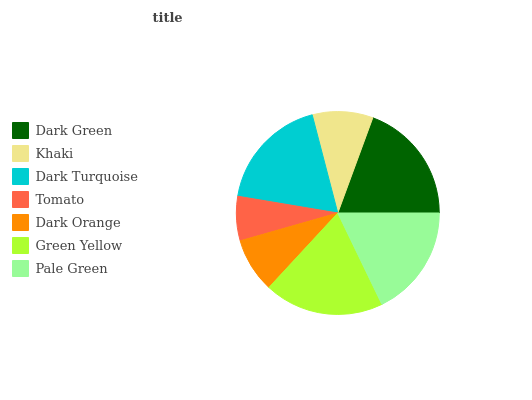Is Tomato the minimum?
Answer yes or no. Yes. Is Dark Green the maximum?
Answer yes or no. Yes. Is Khaki the minimum?
Answer yes or no. No. Is Khaki the maximum?
Answer yes or no. No. Is Dark Green greater than Khaki?
Answer yes or no. Yes. Is Khaki less than Dark Green?
Answer yes or no. Yes. Is Khaki greater than Dark Green?
Answer yes or no. No. Is Dark Green less than Khaki?
Answer yes or no. No. Is Pale Green the high median?
Answer yes or no. Yes. Is Pale Green the low median?
Answer yes or no. Yes. Is Khaki the high median?
Answer yes or no. No. Is Dark Turquoise the low median?
Answer yes or no. No. 